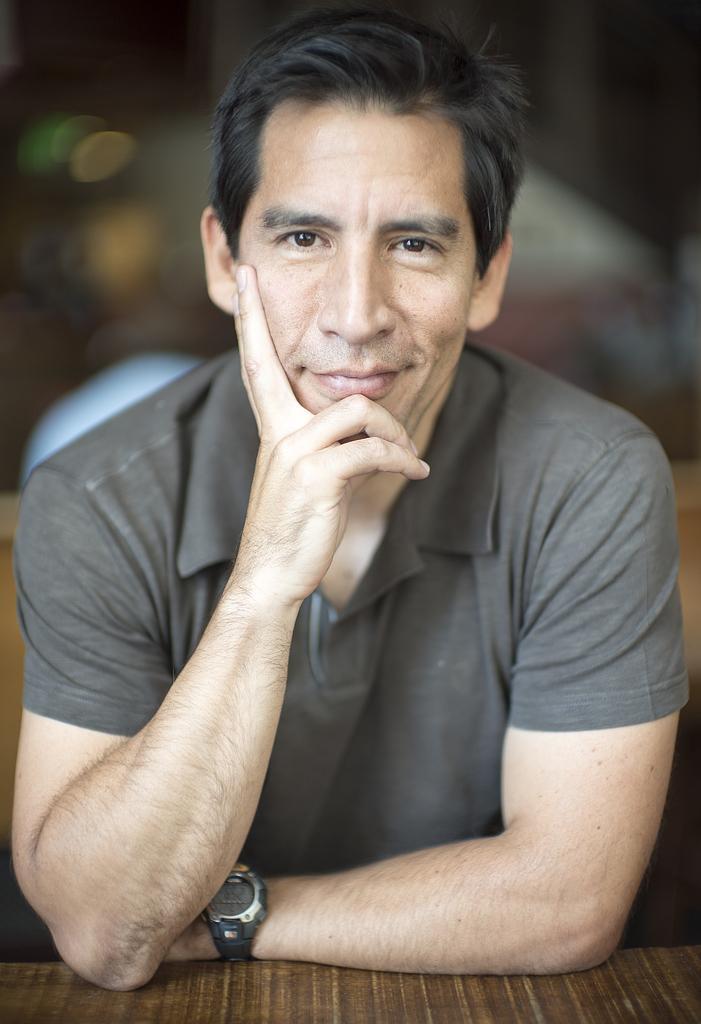Can you describe this image briefly? In this picture I can see a man smiling, there is a table, and there is blur background. 